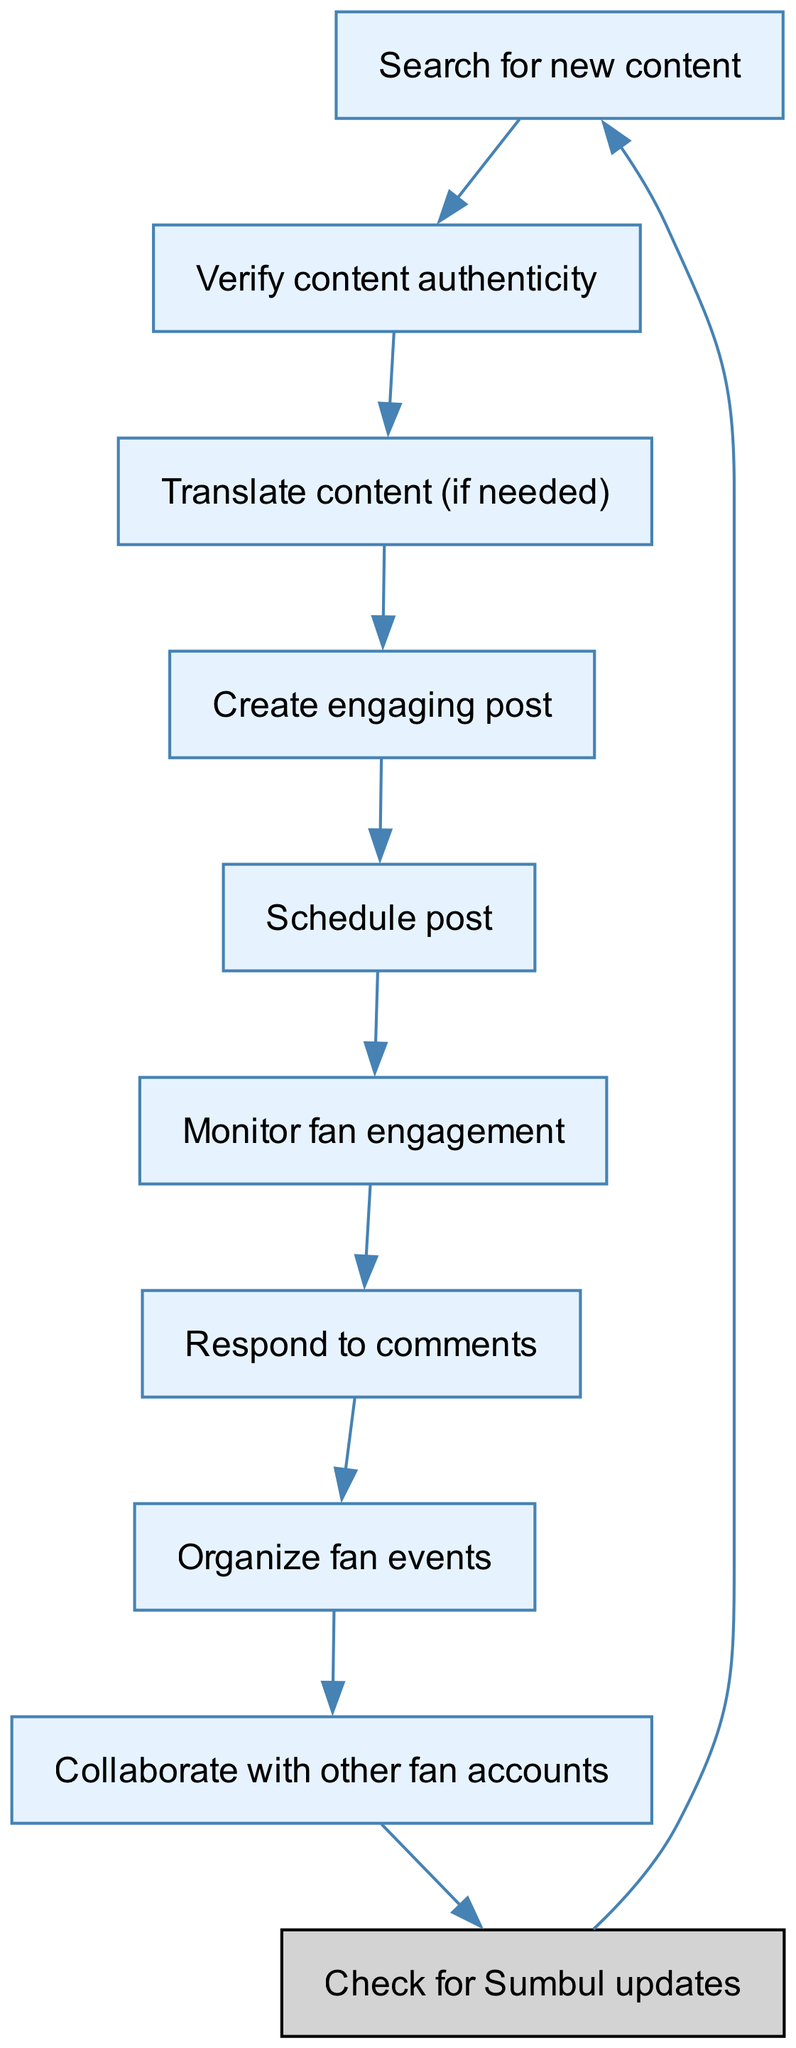What is the starting node in the diagram? The starting node is specified in the data as "Check for Sumbul updates." This node represents the first action in the workflow.
Answer: Check for Sumbul updates How many nodes are present in the diagram? The diagram has a total of 9 nodes listed, including the starting node. Each node represents a distinct action in managing the account.
Answer: 9 What is the last node in the workflow? The last node in the workflow is "Collaborate with other fan accounts." This node indicates the final action before returning to the start node.
Answer: Collaborate with other fan accounts Which node directly follows "Monitor fan engagement"? The node that follows "Monitor fan engagement" is "Respond to comments." This indicates a direct connection for further engagement with fans.
Answer: Respond to comments What is the relationship between "Verify content authenticity" and "Translate content (if needed)"? "Verify content authenticity" directly leads to "Translate content (if needed)." This shows that after verifying, translation is considered if necessary.
Answer: Leads to How many edges connect the nodes in the diagram? There are 9 edges connecting the nodes, indicating the direction of the workflow from one action to the next. Each edge signifies a transition between tasks in the management process.
Answer: 9 What action comes before "Organize fan events"? The action that comes before "Organize fan events" is "Respond to comments." This indicates that engagement and response must happen prior to organizing events.
Answer: Respond to comments Which node represents creating posts? The node that represents creating posts is "Create engaging post." This node is critical in the workflow as it involves formulating content for the audience.
Answer: Create engaging post What follows after creating a post in the workflow? After "Create engaging post," the next action is "Schedule post," which involves planning when the post will go live for the fans to see.
Answer: Schedule post 